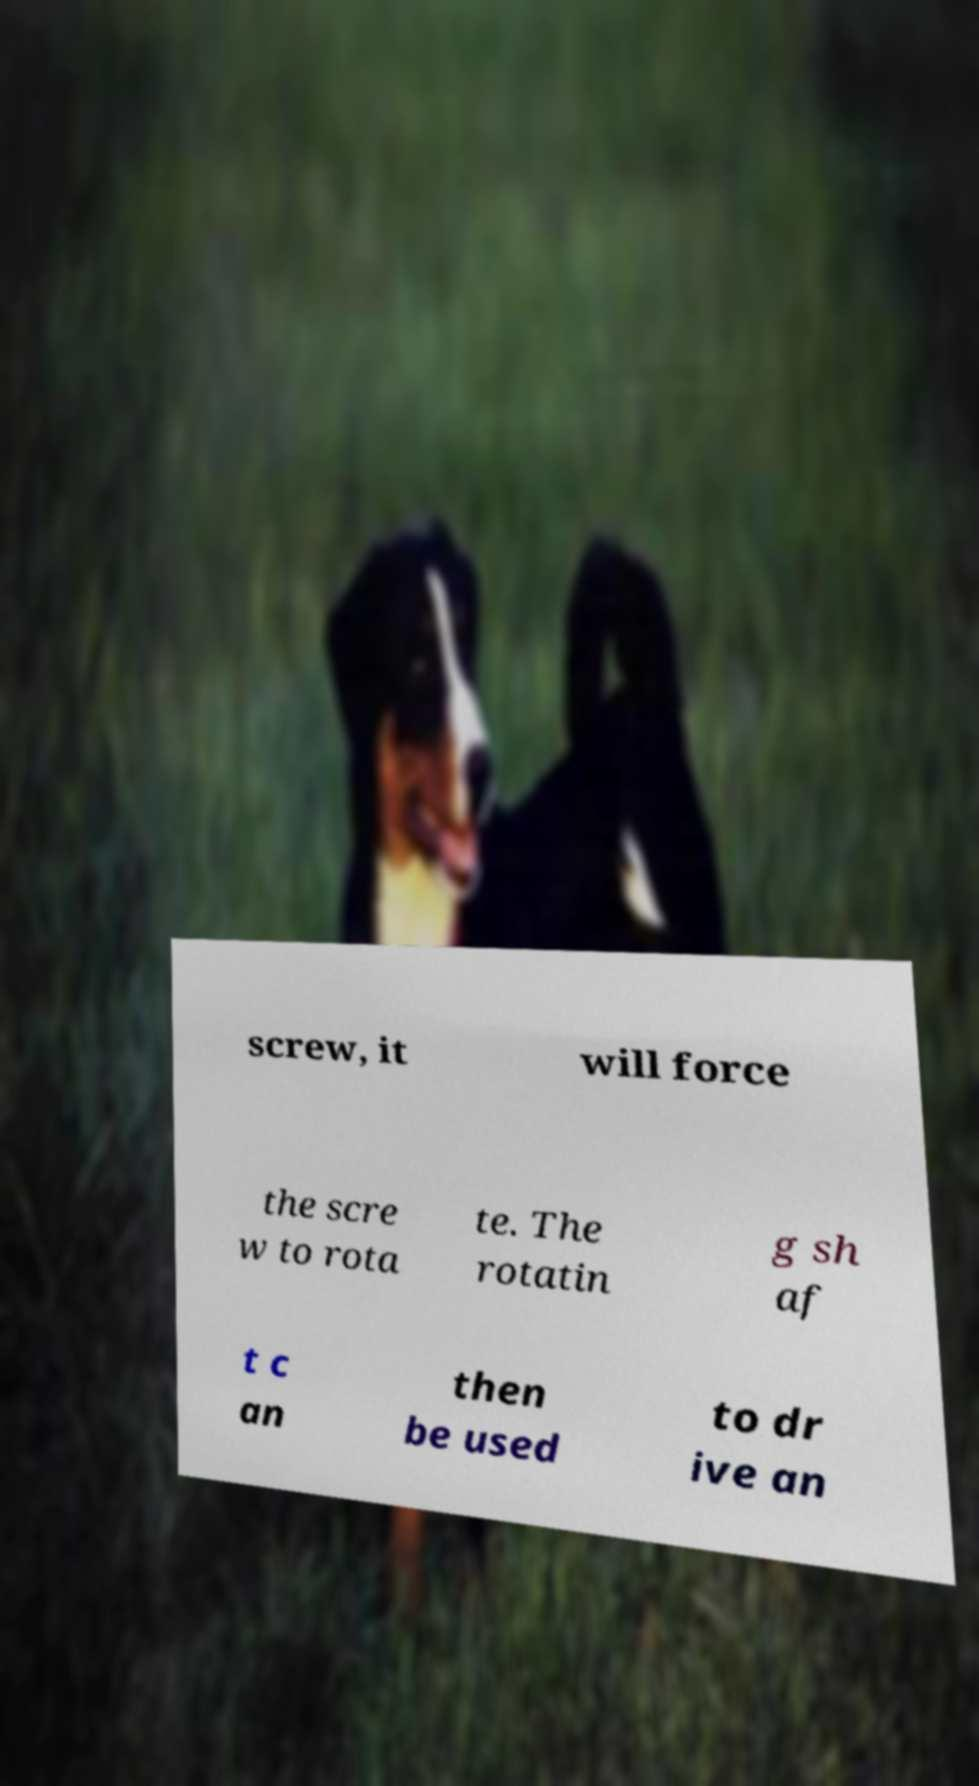For documentation purposes, I need the text within this image transcribed. Could you provide that? screw, it will force the scre w to rota te. The rotatin g sh af t c an then be used to dr ive an 